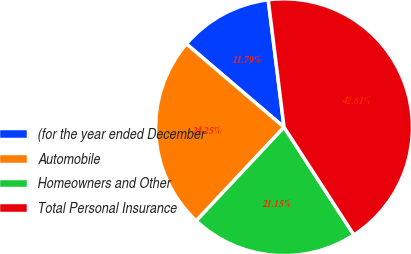Convert chart. <chart><loc_0><loc_0><loc_500><loc_500><pie_chart><fcel>(for the year ended December<fcel>Automobile<fcel>Homeowners and Other<fcel>Total Personal Insurance<nl><fcel>11.79%<fcel>24.25%<fcel>21.15%<fcel>42.81%<nl></chart> 